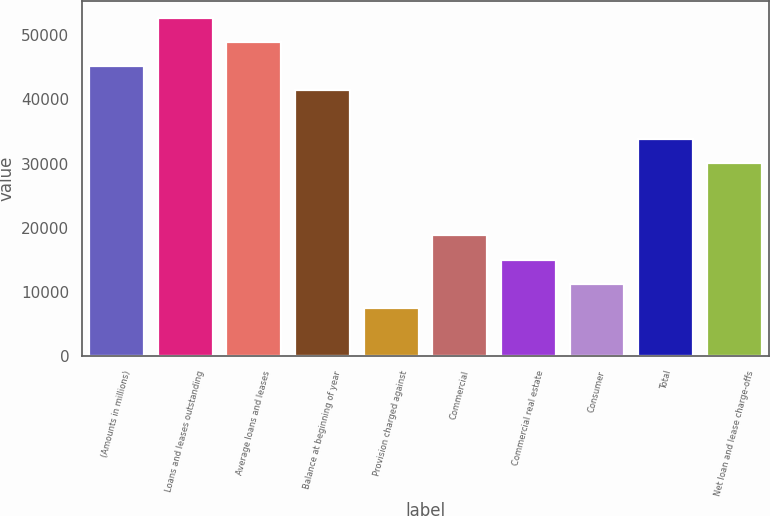Convert chart to OTSL. <chart><loc_0><loc_0><loc_500><loc_500><bar_chart><fcel>(Amounts in millions)<fcel>Loans and leases outstanding<fcel>Average loans and leases<fcel>Balance at beginning of year<fcel>Provision charged against<fcel>Commercial<fcel>Commercial real estate<fcel>Consumer<fcel>Total<fcel>Net loan and lease charge-offs<nl><fcel>45203.9<fcel>52737.9<fcel>48970.9<fcel>41437<fcel>7534.34<fcel>18835.2<fcel>15068.3<fcel>11301.3<fcel>33903.1<fcel>30136.1<nl></chart> 